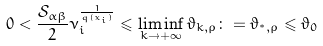Convert formula to latex. <formula><loc_0><loc_0><loc_500><loc_500>0 < \frac { \mathcal { S } _ { \alpha \beta } } { 2 } \nu _ { i } ^ { \frac { 1 } { q ( x _ { i } ) } } \leqslant \liminf _ { k \to + \infty } \vartheta _ { k , \rho } \colon = \vartheta _ { ^ { * } , \rho } \leqslant \vartheta _ { 0 }</formula> 